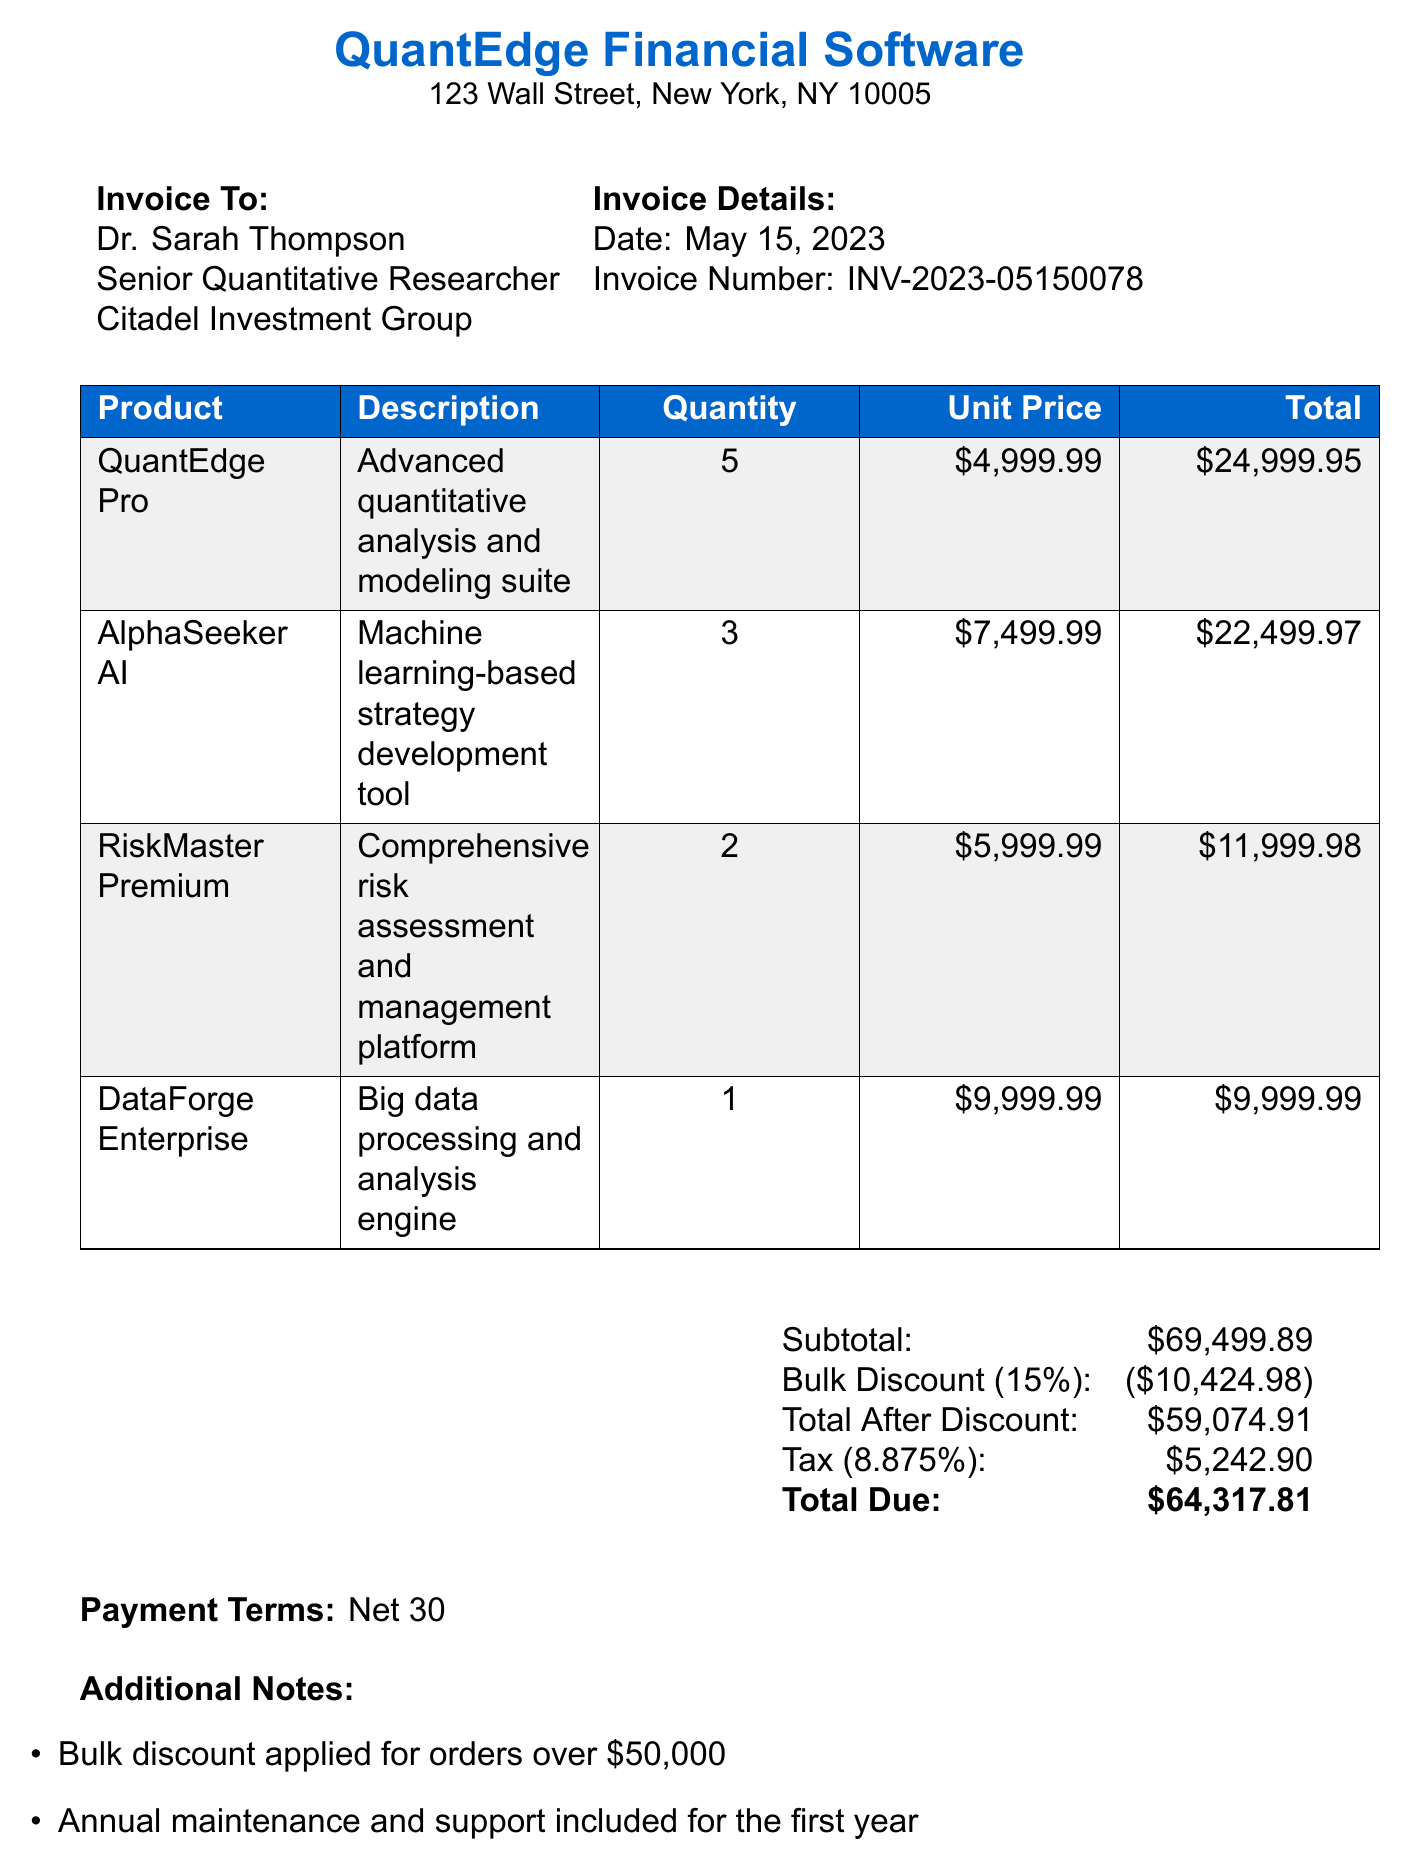What is the company name? The company name is listed at the top of the document.
Answer: QuantEdge Financial Software What is the total due amount? The total due is calculated at the end of the receipt.
Answer: $64,317.81 Who is the invoice issued to? The document specifies the recipient of the invoice.
Answer: Dr. Sarah Thompson What is the bulk discount percentage? The bulk discount percentage is mentioned in the pricing section.
Answer: 15% How many units of RiskMaster Premium were purchased? The quantity of RiskMaster Premium is detailed in the product list.
Answer: 2 What is included for all licensed users? The additional notes section lists benefits for licensed users.
Answer: Free access to QuantEdge Academy What is the tax rate applied? The tax rate is mentioned right before the tax amount in the calculations.
Answer: 8.875% When is payment due? The payment terms are clearly stated towards the end of the document.
Answer: Net 30 What is the role of the customer? The customer’s title is provided in the invoice details section.
Answer: Senior Quantitative Researcher 